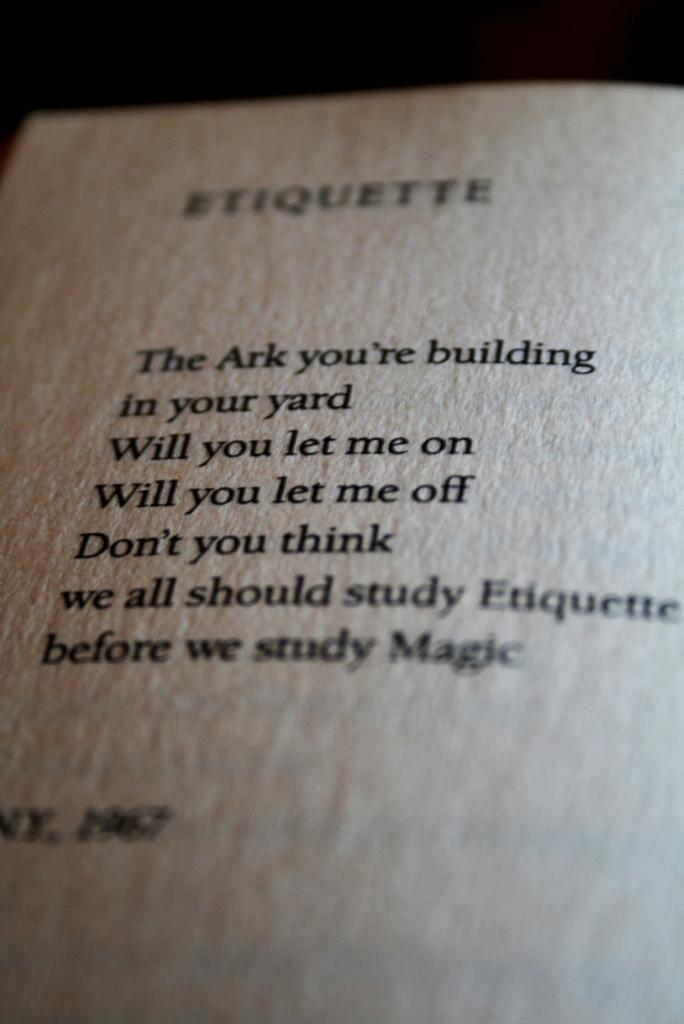<image>
Give a short and clear explanation of the subsequent image. Etiquette chapter book about the ark and studying magic. 